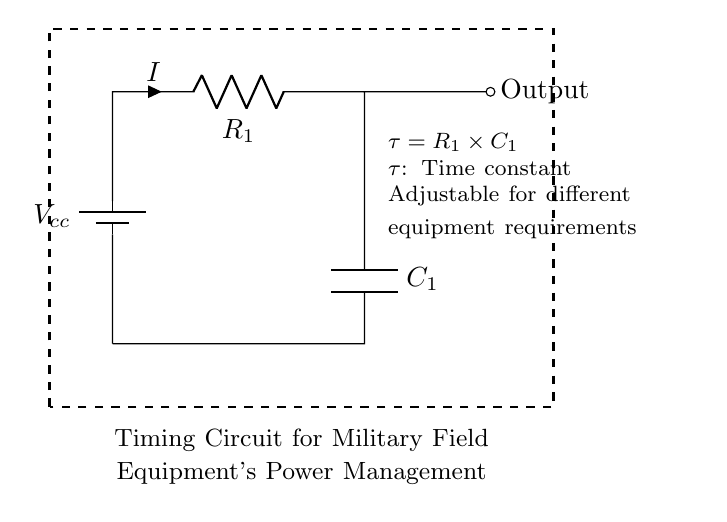What is the voltage source in this circuit? The circuit has a voltage source labeled Vcc located at the top, which indicates the power supply for the circuit.
Answer: Vcc What does the resistor R1 represent in the circuit? The resistor R1 is present in series with the capacitor and is responsible for controlling the charge and discharge rate of the capacitor in the timing circuit.
Answer: Controls timing What is the time constant of the circuit? The time constant is given by the formula τ = R1 × C1, which defines the speed of the circuit’s response to changes in voltage.
Answer: R1 × C1 How many passive components are in this circuit? There are two passive components in this circuit: one resistor (R1) and one capacitor (C1). Passive components do not provide amplification or gain.
Answer: Two What is the purpose of the capacitor C1 in the circuit? The capacitor C1 is used for storing electrical energy and releases it gradually, which is essential for the timing function of this circuit.
Answer: Energy storage What happens to the output when voltage is applied? When voltage is applied, the capacitor begins to charge through the resistor, creating a delay before the output reaches its final state, due to the time constant τ.
Answer: Charges and delays What does the dashed rectangle indicate in this circuit diagram? The dashed rectangle surrounding the circuit components signifies the overall boundary of the timing circuit, indicating that everything inside is part of a single functional unit.
Answer: Circuit boundary 